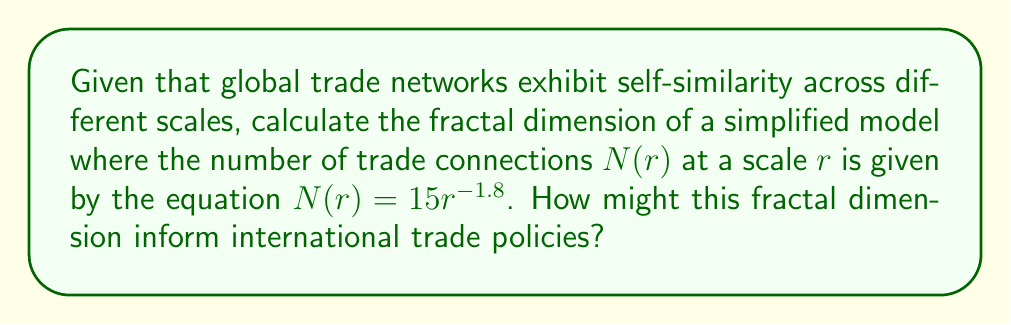Can you solve this math problem? To calculate the fractal dimension of the global trade network model, we'll use the box-counting method, which is fundamental in fractal analysis. The fractal dimension $D$ is given by the equation:

$$D = -\lim_{r \to 0} \frac{\log N(r)}{\log r}$$

Where $N(r)$ is the number of boxes (in this case, trade connections) of size $r$ needed to cover the fractal.

Given: $N(r) = 15r^{-1.8}$

Step 1: Take the logarithm of both sides of the equation:
$$\log N(r) = \log(15r^{-1.8})$$
$$\log N(r) = \log 15 - 1.8 \log r$$

Step 2: Rearrange to match the form of the fractal dimension equation:
$$-\frac{\log N(r)}{\log r} = 1.8 - \frac{\log 15}{\log r}$$

Step 3: Take the limit as $r$ approaches 0:
$$\lim_{r \to 0} -\frac{\log N(r)}{\log r} = \lim_{r \to 0} (1.8 - \frac{\log 15}{\log r}) = 1.8$$

Therefore, the fractal dimension $D = 1.8$.

This fractal dimension of 1.8 suggests that the global trade network is more complex than a simple line (dimension 1) but less intricate than a fully filled plane (dimension 2). In terms of international trade policies, this dimension implies:

1. The trade network has a high degree of complexity and interconnectedness.
2. Trade relationships exist across multiple scales, from local to global.
3. There's potential for cascading effects in the network, where changes in one part can rapidly influence distant parts.
4. Policymakers should consider multi-scale approaches when designing trade agreements or interventions.
5. The network's structure might be resilient to random disruptions but potentially vulnerable to targeted interventions at key nodes.

Understanding this fractal nature can help diplomats and policymakers craft more nuanced and effective international trade strategies that account for the network's complex structure.
Answer: $D = 1.8$ 